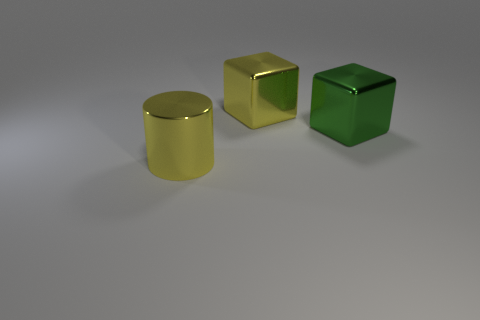How big is the yellow thing to the left of the yellow metallic thing behind the large yellow metallic thing in front of the yellow metallic block?
Ensure brevity in your answer.  Large. What number of other things are the same material as the large yellow cylinder?
Give a very brief answer. 2. How many large yellow things are the same shape as the large green metallic object?
Provide a succinct answer. 1. There is a thing that is both to the left of the green metal block and in front of the large yellow metal cube; what is its color?
Keep it short and to the point. Yellow. What number of purple metallic things are there?
Your response must be concise. 0. Is the size of the green metallic object the same as the cylinder?
Make the answer very short. Yes. Are there any small metallic objects of the same color as the cylinder?
Keep it short and to the point. No. There is a yellow shiny thing that is behind the metal cylinder; does it have the same shape as the green metallic thing?
Your answer should be very brief. Yes. How many yellow things are the same size as the yellow cylinder?
Give a very brief answer. 1. How many yellow shiny objects are to the right of the big yellow metal object that is in front of the large yellow cube?
Make the answer very short. 1. 